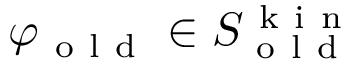Convert formula to latex. <formula><loc_0><loc_0><loc_500><loc_500>\varphi _ { o l d } \in S _ { o l d } ^ { k i n }</formula> 